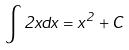<formula> <loc_0><loc_0><loc_500><loc_500>\int 2 x d x = x ^ { 2 } + C</formula> 